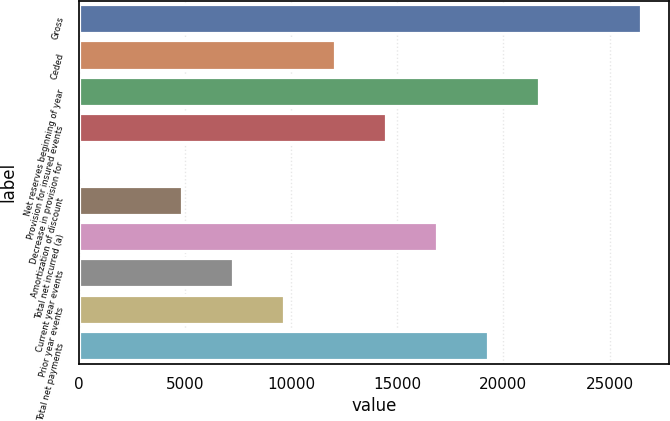<chart> <loc_0><loc_0><loc_500><loc_500><bar_chart><fcel>Gross<fcel>Ceded<fcel>Net reserves beginning of year<fcel>Provision for insured events<fcel>Decrease in provision for<fcel>Amortization of discount<fcel>Total net incurred (a)<fcel>Current year events<fcel>Prior year events<fcel>Total net payments<nl><fcel>26494.3<fcel>12062.5<fcel>21683.7<fcel>14467.8<fcel>36<fcel>4846.6<fcel>16873.1<fcel>7251.9<fcel>9657.2<fcel>19278.4<nl></chart> 